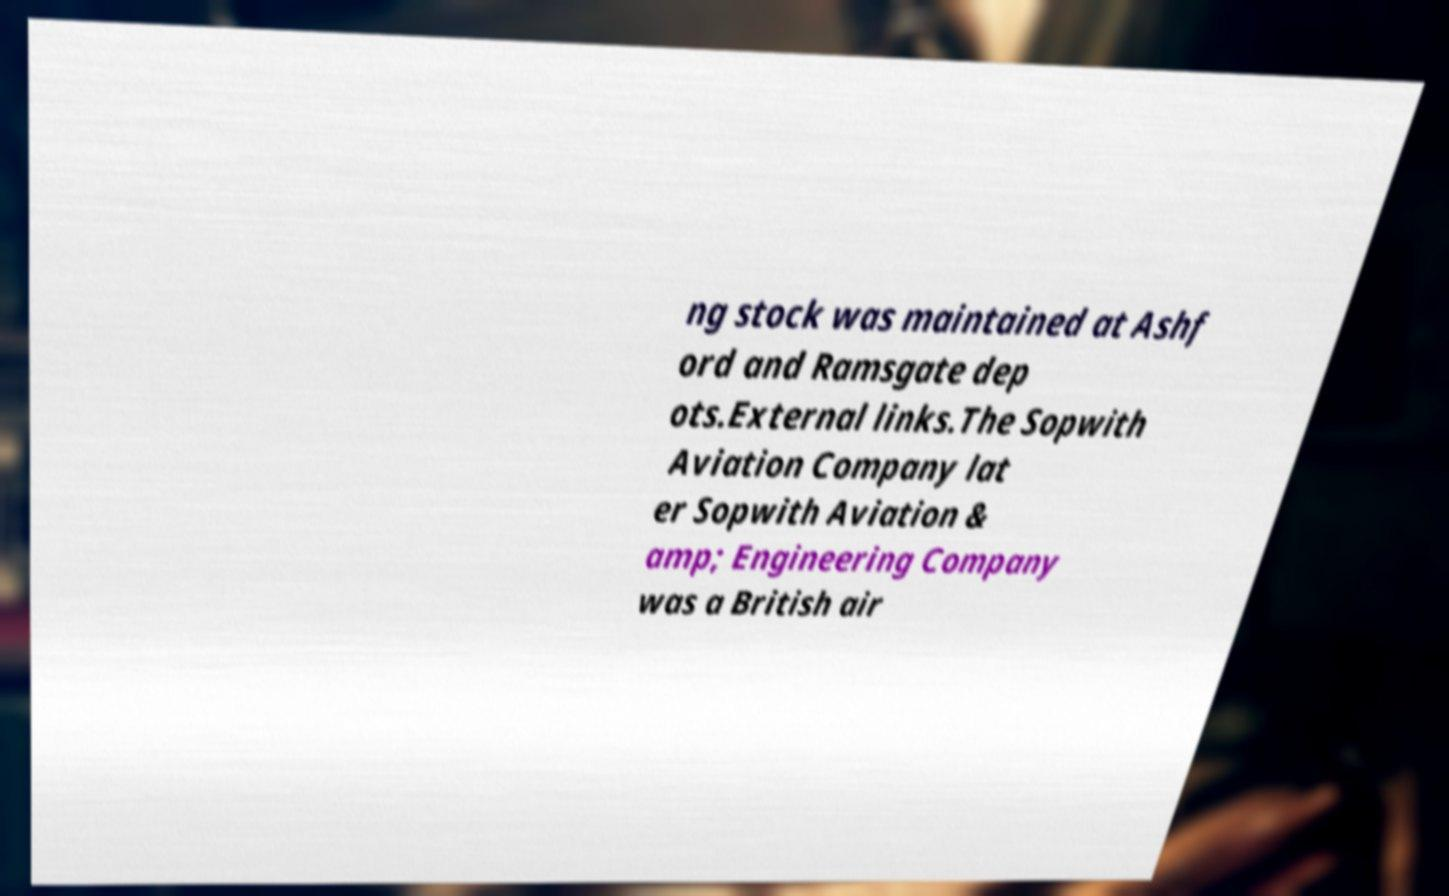Can you read and provide the text displayed in the image?This photo seems to have some interesting text. Can you extract and type it out for me? ng stock was maintained at Ashf ord and Ramsgate dep ots.External links.The Sopwith Aviation Company lat er Sopwith Aviation & amp; Engineering Company was a British air 